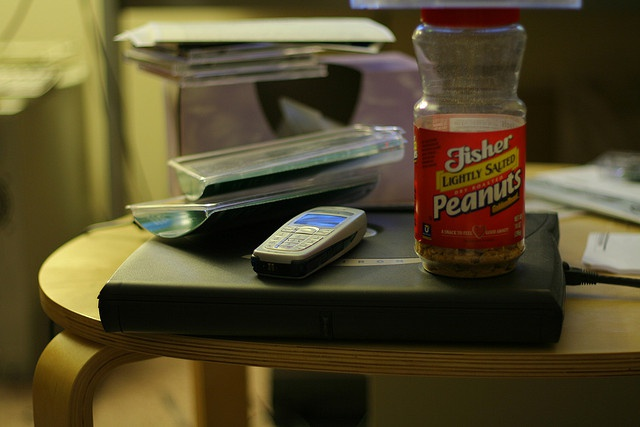Describe the objects in this image and their specific colors. I can see laptop in khaki, black, gray, tan, and darkgreen tones, bottle in khaki, maroon, black, olive, and gray tones, and cell phone in khaki, black, darkgray, and tan tones in this image. 